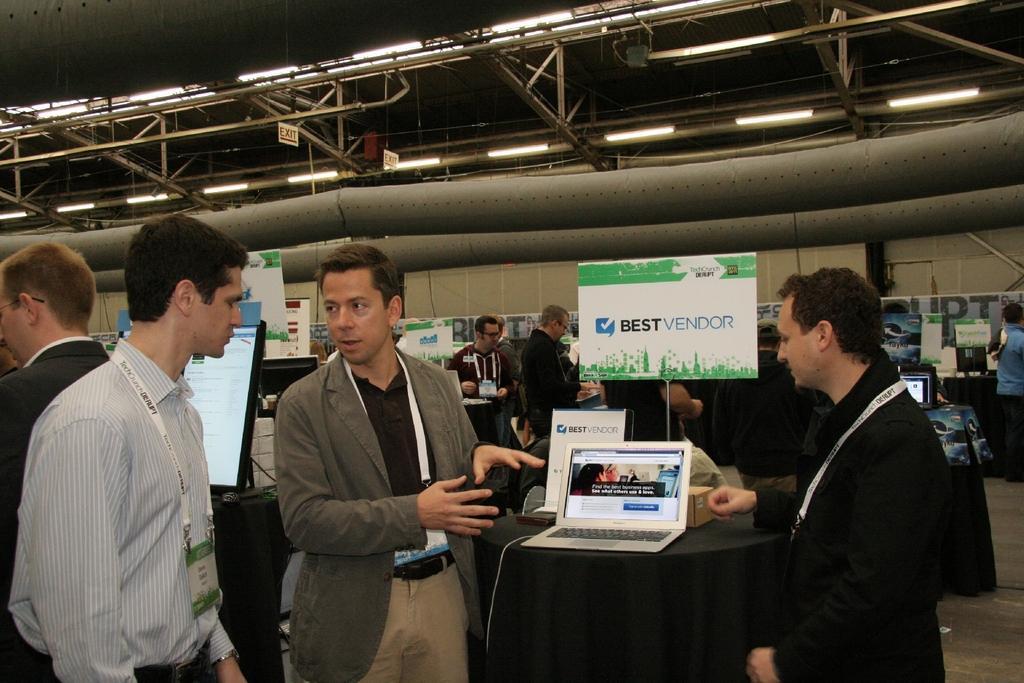Describe this image in one or two sentences. In this image, we can see people standing and wearing is cards and there are laptops and some other objects are on the tables. In the background, we can see boards and some other people and some banners. At the top, there are lights, rods and there is roof and at the bottom, there is floor. 